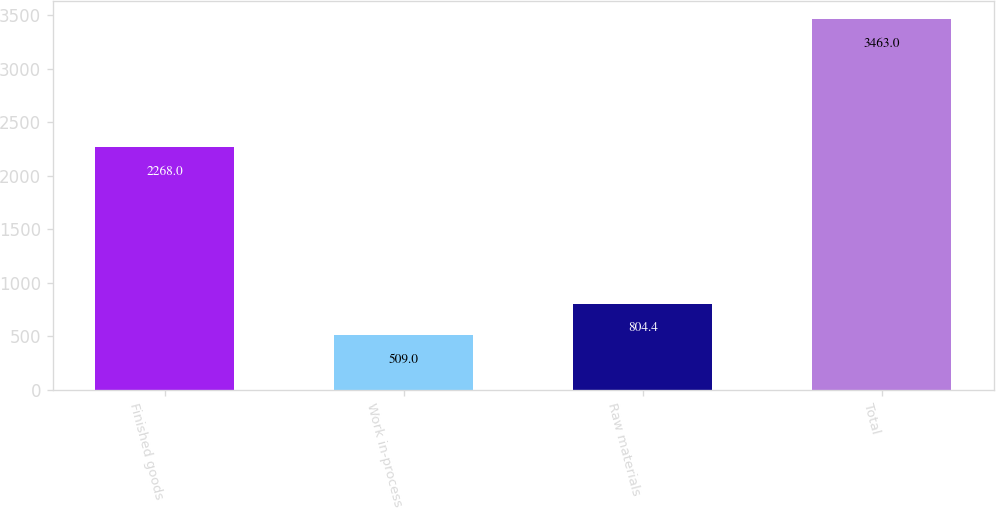<chart> <loc_0><loc_0><loc_500><loc_500><bar_chart><fcel>Finished goods<fcel>Work in-process<fcel>Raw materials<fcel>Total<nl><fcel>2268<fcel>509<fcel>804.4<fcel>3463<nl></chart> 